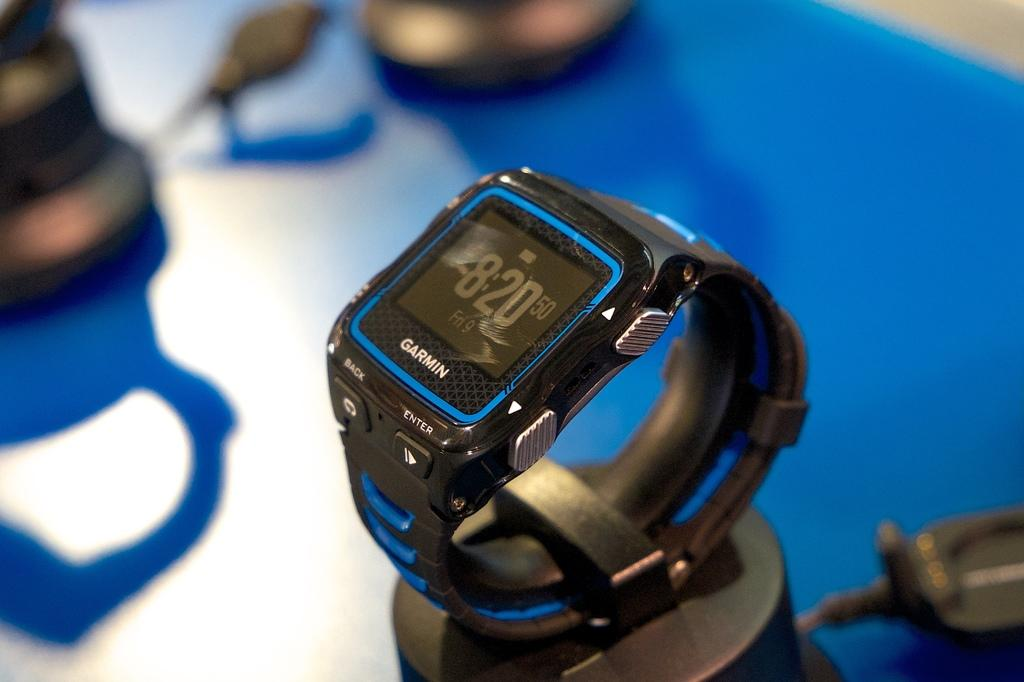Provide a one-sentence caption for the provided image. A watch made by the brand Garmin that is blue and black. 